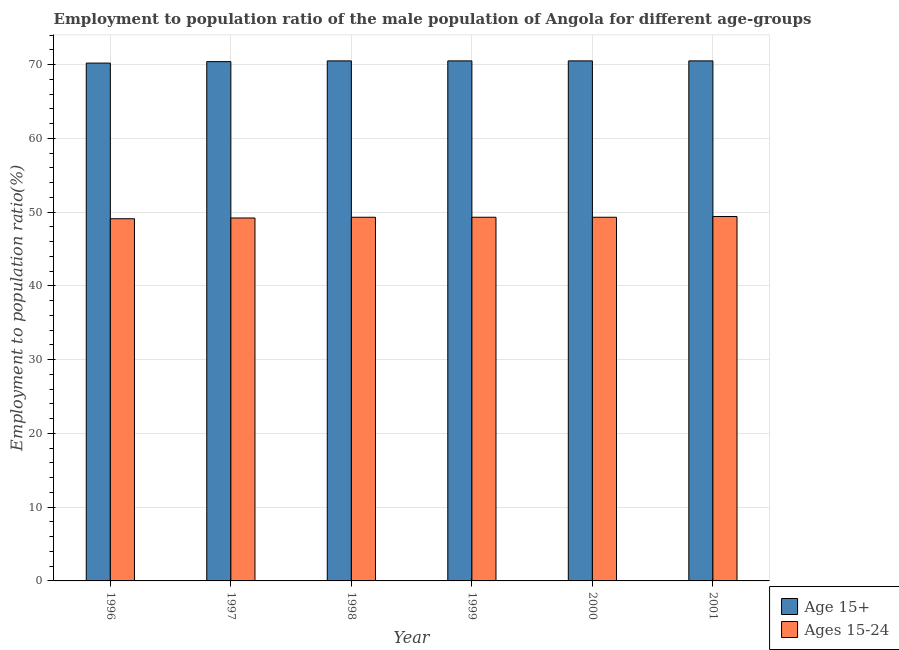Are the number of bars per tick equal to the number of legend labels?
Offer a very short reply. Yes. How many bars are there on the 3rd tick from the left?
Offer a very short reply. 2. What is the label of the 3rd group of bars from the left?
Ensure brevity in your answer.  1998. What is the employment to population ratio(age 15+) in 1999?
Your answer should be very brief. 70.5. Across all years, what is the maximum employment to population ratio(age 15-24)?
Give a very brief answer. 49.4. Across all years, what is the minimum employment to population ratio(age 15-24)?
Make the answer very short. 49.1. What is the total employment to population ratio(age 15-24) in the graph?
Offer a very short reply. 295.6. What is the difference between the employment to population ratio(age 15+) in 1996 and that in 2000?
Provide a short and direct response. -0.3. What is the difference between the employment to population ratio(age 15-24) in 1997 and the employment to population ratio(age 15+) in 2000?
Give a very brief answer. -0.1. What is the average employment to population ratio(age 15-24) per year?
Keep it short and to the point. 49.27. What is the ratio of the employment to population ratio(age 15-24) in 1996 to that in 1997?
Provide a succinct answer. 1. What is the difference between the highest and the second highest employment to population ratio(age 15+)?
Offer a terse response. 0. What is the difference between the highest and the lowest employment to population ratio(age 15-24)?
Make the answer very short. 0.3. In how many years, is the employment to population ratio(age 15+) greater than the average employment to population ratio(age 15+) taken over all years?
Make the answer very short. 4. Is the sum of the employment to population ratio(age 15-24) in 1998 and 2001 greater than the maximum employment to population ratio(age 15+) across all years?
Provide a short and direct response. Yes. What does the 2nd bar from the left in 1999 represents?
Give a very brief answer. Ages 15-24. What does the 2nd bar from the right in 1996 represents?
Your answer should be very brief. Age 15+. Are all the bars in the graph horizontal?
Provide a succinct answer. No. How many years are there in the graph?
Offer a very short reply. 6. Where does the legend appear in the graph?
Provide a short and direct response. Bottom right. How many legend labels are there?
Your answer should be very brief. 2. What is the title of the graph?
Make the answer very short. Employment to population ratio of the male population of Angola for different age-groups. What is the Employment to population ratio(%) of Age 15+ in 1996?
Give a very brief answer. 70.2. What is the Employment to population ratio(%) in Ages 15-24 in 1996?
Make the answer very short. 49.1. What is the Employment to population ratio(%) in Age 15+ in 1997?
Provide a short and direct response. 70.4. What is the Employment to population ratio(%) of Ages 15-24 in 1997?
Offer a very short reply. 49.2. What is the Employment to population ratio(%) in Age 15+ in 1998?
Ensure brevity in your answer.  70.5. What is the Employment to population ratio(%) in Ages 15-24 in 1998?
Your answer should be very brief. 49.3. What is the Employment to population ratio(%) in Age 15+ in 1999?
Make the answer very short. 70.5. What is the Employment to population ratio(%) in Ages 15-24 in 1999?
Make the answer very short. 49.3. What is the Employment to population ratio(%) in Age 15+ in 2000?
Your response must be concise. 70.5. What is the Employment to population ratio(%) of Ages 15-24 in 2000?
Your response must be concise. 49.3. What is the Employment to population ratio(%) in Age 15+ in 2001?
Provide a succinct answer. 70.5. What is the Employment to population ratio(%) of Ages 15-24 in 2001?
Keep it short and to the point. 49.4. Across all years, what is the maximum Employment to population ratio(%) of Age 15+?
Ensure brevity in your answer.  70.5. Across all years, what is the maximum Employment to population ratio(%) in Ages 15-24?
Your answer should be compact. 49.4. Across all years, what is the minimum Employment to population ratio(%) in Age 15+?
Provide a short and direct response. 70.2. Across all years, what is the minimum Employment to population ratio(%) in Ages 15-24?
Your response must be concise. 49.1. What is the total Employment to population ratio(%) in Age 15+ in the graph?
Your answer should be very brief. 422.6. What is the total Employment to population ratio(%) in Ages 15-24 in the graph?
Offer a very short reply. 295.6. What is the difference between the Employment to population ratio(%) of Age 15+ in 1996 and that in 1997?
Give a very brief answer. -0.2. What is the difference between the Employment to population ratio(%) of Ages 15-24 in 1996 and that in 1998?
Give a very brief answer. -0.2. What is the difference between the Employment to population ratio(%) of Age 15+ in 1996 and that in 1999?
Provide a short and direct response. -0.3. What is the difference between the Employment to population ratio(%) of Ages 15-24 in 1996 and that in 1999?
Your answer should be compact. -0.2. What is the difference between the Employment to population ratio(%) of Age 15+ in 1996 and that in 2000?
Make the answer very short. -0.3. What is the difference between the Employment to population ratio(%) of Ages 15-24 in 1996 and that in 2000?
Your answer should be compact. -0.2. What is the difference between the Employment to population ratio(%) in Ages 15-24 in 1997 and that in 1999?
Your response must be concise. -0.1. What is the difference between the Employment to population ratio(%) in Ages 15-24 in 1997 and that in 2000?
Provide a short and direct response. -0.1. What is the difference between the Employment to population ratio(%) in Age 15+ in 1997 and that in 2001?
Provide a short and direct response. -0.1. What is the difference between the Employment to population ratio(%) of Ages 15-24 in 1997 and that in 2001?
Make the answer very short. -0.2. What is the difference between the Employment to population ratio(%) of Age 15+ in 1998 and that in 1999?
Give a very brief answer. 0. What is the difference between the Employment to population ratio(%) of Age 15+ in 1999 and that in 2000?
Your response must be concise. 0. What is the difference between the Employment to population ratio(%) in Age 15+ in 1999 and that in 2001?
Your answer should be very brief. 0. What is the difference between the Employment to population ratio(%) in Ages 15-24 in 1999 and that in 2001?
Give a very brief answer. -0.1. What is the difference between the Employment to population ratio(%) in Age 15+ in 2000 and that in 2001?
Make the answer very short. 0. What is the difference between the Employment to population ratio(%) of Ages 15-24 in 2000 and that in 2001?
Offer a very short reply. -0.1. What is the difference between the Employment to population ratio(%) of Age 15+ in 1996 and the Employment to population ratio(%) of Ages 15-24 in 1998?
Ensure brevity in your answer.  20.9. What is the difference between the Employment to population ratio(%) in Age 15+ in 1996 and the Employment to population ratio(%) in Ages 15-24 in 1999?
Your answer should be compact. 20.9. What is the difference between the Employment to population ratio(%) in Age 15+ in 1996 and the Employment to population ratio(%) in Ages 15-24 in 2000?
Offer a very short reply. 20.9. What is the difference between the Employment to population ratio(%) of Age 15+ in 1996 and the Employment to population ratio(%) of Ages 15-24 in 2001?
Keep it short and to the point. 20.8. What is the difference between the Employment to population ratio(%) of Age 15+ in 1997 and the Employment to population ratio(%) of Ages 15-24 in 1998?
Ensure brevity in your answer.  21.1. What is the difference between the Employment to population ratio(%) of Age 15+ in 1997 and the Employment to population ratio(%) of Ages 15-24 in 1999?
Keep it short and to the point. 21.1. What is the difference between the Employment to population ratio(%) in Age 15+ in 1997 and the Employment to population ratio(%) in Ages 15-24 in 2000?
Your answer should be compact. 21.1. What is the difference between the Employment to population ratio(%) of Age 15+ in 1998 and the Employment to population ratio(%) of Ages 15-24 in 1999?
Ensure brevity in your answer.  21.2. What is the difference between the Employment to population ratio(%) of Age 15+ in 1998 and the Employment to population ratio(%) of Ages 15-24 in 2000?
Give a very brief answer. 21.2. What is the difference between the Employment to population ratio(%) of Age 15+ in 1998 and the Employment to population ratio(%) of Ages 15-24 in 2001?
Your answer should be very brief. 21.1. What is the difference between the Employment to population ratio(%) of Age 15+ in 1999 and the Employment to population ratio(%) of Ages 15-24 in 2000?
Your answer should be very brief. 21.2. What is the difference between the Employment to population ratio(%) in Age 15+ in 1999 and the Employment to population ratio(%) in Ages 15-24 in 2001?
Provide a short and direct response. 21.1. What is the difference between the Employment to population ratio(%) in Age 15+ in 2000 and the Employment to population ratio(%) in Ages 15-24 in 2001?
Give a very brief answer. 21.1. What is the average Employment to population ratio(%) of Age 15+ per year?
Your answer should be very brief. 70.43. What is the average Employment to population ratio(%) in Ages 15-24 per year?
Provide a short and direct response. 49.27. In the year 1996, what is the difference between the Employment to population ratio(%) of Age 15+ and Employment to population ratio(%) of Ages 15-24?
Offer a very short reply. 21.1. In the year 1997, what is the difference between the Employment to population ratio(%) in Age 15+ and Employment to population ratio(%) in Ages 15-24?
Offer a very short reply. 21.2. In the year 1998, what is the difference between the Employment to population ratio(%) in Age 15+ and Employment to population ratio(%) in Ages 15-24?
Give a very brief answer. 21.2. In the year 1999, what is the difference between the Employment to population ratio(%) in Age 15+ and Employment to population ratio(%) in Ages 15-24?
Your answer should be very brief. 21.2. In the year 2000, what is the difference between the Employment to population ratio(%) of Age 15+ and Employment to population ratio(%) of Ages 15-24?
Keep it short and to the point. 21.2. In the year 2001, what is the difference between the Employment to population ratio(%) in Age 15+ and Employment to population ratio(%) in Ages 15-24?
Your response must be concise. 21.1. What is the ratio of the Employment to population ratio(%) in Age 15+ in 1996 to that in 1997?
Offer a very short reply. 1. What is the ratio of the Employment to population ratio(%) of Age 15+ in 1996 to that in 1998?
Give a very brief answer. 1. What is the ratio of the Employment to population ratio(%) of Age 15+ in 1996 to that in 1999?
Your answer should be very brief. 1. What is the ratio of the Employment to population ratio(%) of Ages 15-24 in 1996 to that in 1999?
Give a very brief answer. 1. What is the ratio of the Employment to population ratio(%) in Ages 15-24 in 1996 to that in 2000?
Give a very brief answer. 1. What is the ratio of the Employment to population ratio(%) in Age 15+ in 1997 to that in 1999?
Your answer should be compact. 1. What is the ratio of the Employment to population ratio(%) in Ages 15-24 in 1997 to that in 1999?
Provide a succinct answer. 1. What is the ratio of the Employment to population ratio(%) in Age 15+ in 1998 to that in 1999?
Give a very brief answer. 1. What is the ratio of the Employment to population ratio(%) of Ages 15-24 in 1998 to that in 1999?
Offer a terse response. 1. What is the ratio of the Employment to population ratio(%) in Age 15+ in 1999 to that in 2000?
Provide a short and direct response. 1. What is the ratio of the Employment to population ratio(%) of Age 15+ in 1999 to that in 2001?
Provide a succinct answer. 1. What is the ratio of the Employment to population ratio(%) in Ages 15-24 in 1999 to that in 2001?
Give a very brief answer. 1. What is the ratio of the Employment to population ratio(%) of Age 15+ in 2000 to that in 2001?
Keep it short and to the point. 1. What is the difference between the highest and the lowest Employment to population ratio(%) in Ages 15-24?
Your response must be concise. 0.3. 